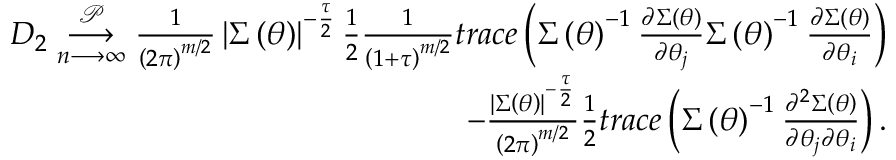<formula> <loc_0><loc_0><loc_500><loc_500>\begin{array} { r l r } & { D _ { 2 } \underset { n \longrightarrow \infty } { \overset { \mathcal { P } } { \longrightarrow } } \frac { 1 } { \left ( 2 \pi \right ) ^ { m / 2 } } \left | \Sigma \left ( \theta \right ) \right | ^ { - \frac { \tau } { 2 } } \frac { 1 } { 2 } \frac { 1 } { \left ( 1 + \tau \right ) ^ { m / 2 } } t r a c e \left ( \Sigma \left ( \theta \right ) ^ { - 1 } \frac { \partial \Sigma \left ( \theta \right ) } { \partial \theta _ { j } } \Sigma \left ( \theta \right ) ^ { - 1 } \frac { \partial \Sigma \left ( \theta \right ) } { \partial \theta _ { i } } \right ) } \\ & { - \frac { \left | \Sigma \left ( \theta \right ) \right | ^ { - \frac { \tau } { 2 } } } { \left ( 2 \pi \right ) ^ { m / 2 } } \frac { 1 } { 2 } t r a c e \left ( \Sigma \left ( \theta \right ) ^ { - 1 } \frac { \partial ^ { 2 } \Sigma \left ( \theta \right ) } { \partial \theta _ { j } \partial \theta _ { i } } \right ) . } \end{array}</formula> 